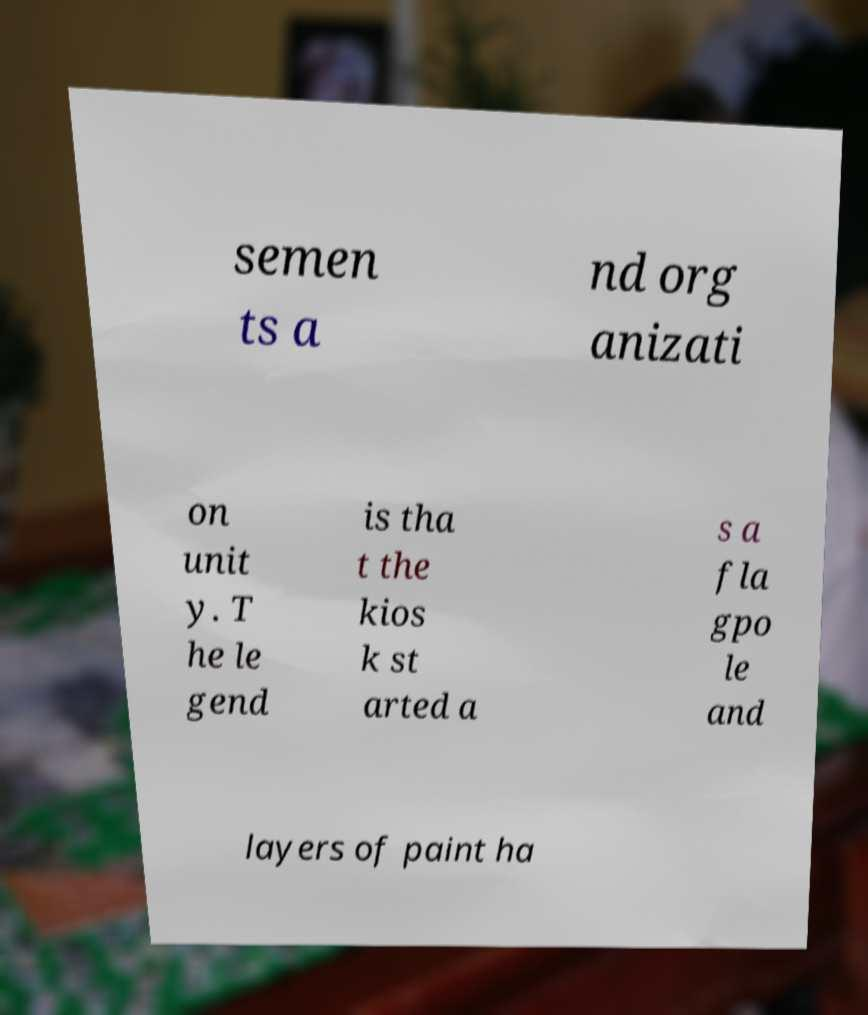Can you accurately transcribe the text from the provided image for me? semen ts a nd org anizati on unit y. T he le gend is tha t the kios k st arted a s a fla gpo le and layers of paint ha 